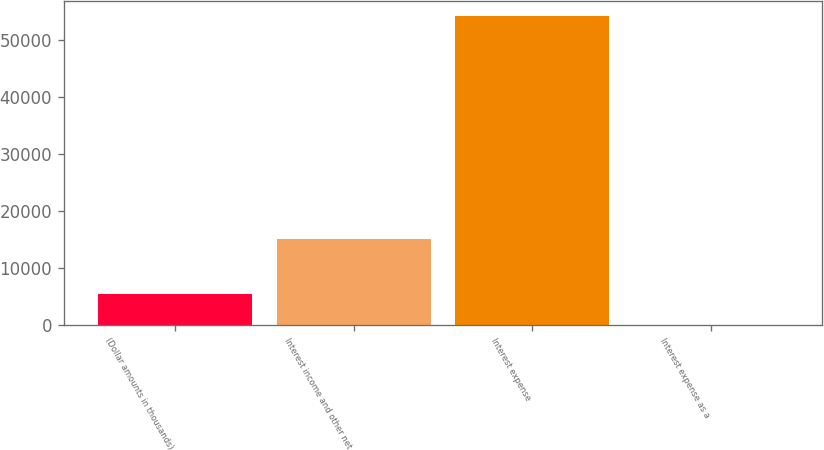Convert chart. <chart><loc_0><loc_0><loc_500><loc_500><bar_chart><fcel>(Dollar amounts in thousands)<fcel>Interest income and other net<fcel>Interest expense<fcel>Interest expense as a<nl><fcel>5419.4<fcel>15112<fcel>54176<fcel>2<nl></chart> 